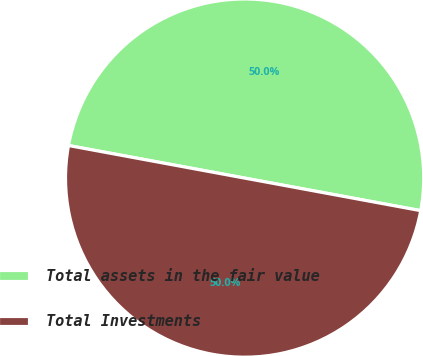Convert chart to OTSL. <chart><loc_0><loc_0><loc_500><loc_500><pie_chart><fcel>Total assets in the fair value<fcel>Total Investments<nl><fcel>50.0%<fcel>50.0%<nl></chart> 